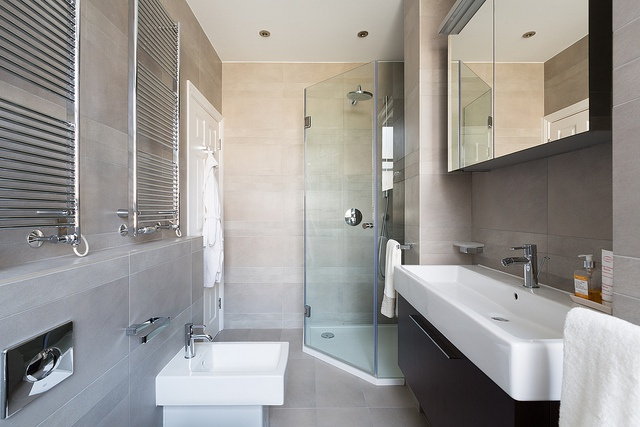Describe the objects in this image and their specific colors. I can see sink in gray, darkgray, and lightgray tones, sink in gray, lightgray, and darkgray tones, and bottle in gray, darkgray, maroon, and olive tones in this image. 